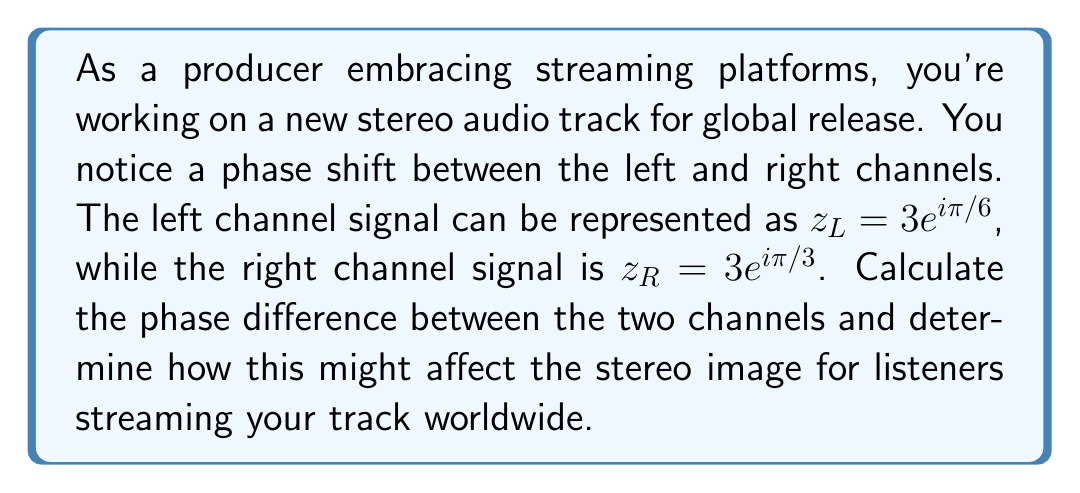Provide a solution to this math problem. To solve this problem, we need to analyze the complex numbers representing the left and right channel signals:

1) Left channel: $z_L = 3e^{i\pi/6}$
2) Right channel: $z_R = 3e^{i\pi/3}$

The phase of a complex number in the form $re^{i\theta}$ is given by $\theta$. So:

3) Phase of left channel: $\theta_L = \pi/6$
4) Phase of right channel: $\theta_R = \pi/3$

To find the phase difference, we subtract the phases:

5) Phase difference = $\theta_R - \theta_L = \pi/3 - \pi/6 = \pi/6$

To convert this to degrees:

6) Phase difference in degrees = $(\pi/6) \cdot (180°/\pi) = 30°$

This phase difference will affect the stereo image in the following ways:

7) It creates a sense of spaciousness in the stereo field.
8) It can enhance the perceived width of the stereo image.
9) However, it may cause some phase cancellation when the track is summed to mono, which could be an issue for listeners using mono devices.

[asy]
import graph;
size(200);
draw(circle((0,0),3));
draw((-4,0)--(4,0),Arrow);
draw((0,-4)--(0,4),Arrow);
draw((0,0)--(3*cos(pi/6),3*sin(pi/6)),red,Arrow);
draw((0,0)--(3*cos(pi/3),3*sin(pi/3)),blue,Arrow);
label("$z_L$",(3*cos(pi/6),3*sin(pi/6)),NE,red);
label("$z_R$",(3*cos(pi/3),3*sin(pi/3)),NW,blue);
draw(arc((0,0),1,30,60),green);
label("$\pi/6$",(1.2,0.4),green);
[/asy]
Answer: The phase difference between the left and right channels is $\pi/6$ radians or 30°. This creates a wider stereo image but may cause phase cancellation issues in mono playback. 